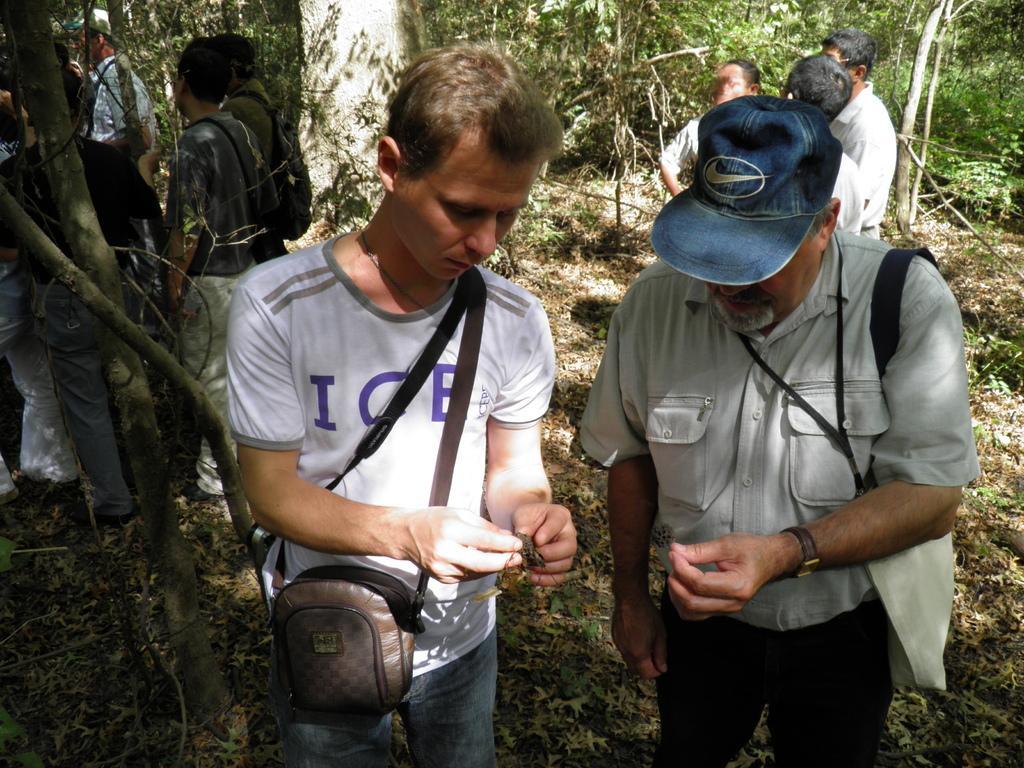In one or two sentences, can you explain what this image depicts? In this image I see number of people in which these 2 men are holding things in their hands and I see that they're carrying bags and I see that this man is wearing a blue color cap on his head and I see the ground on which there are leaves and in the background I see number of trees. 